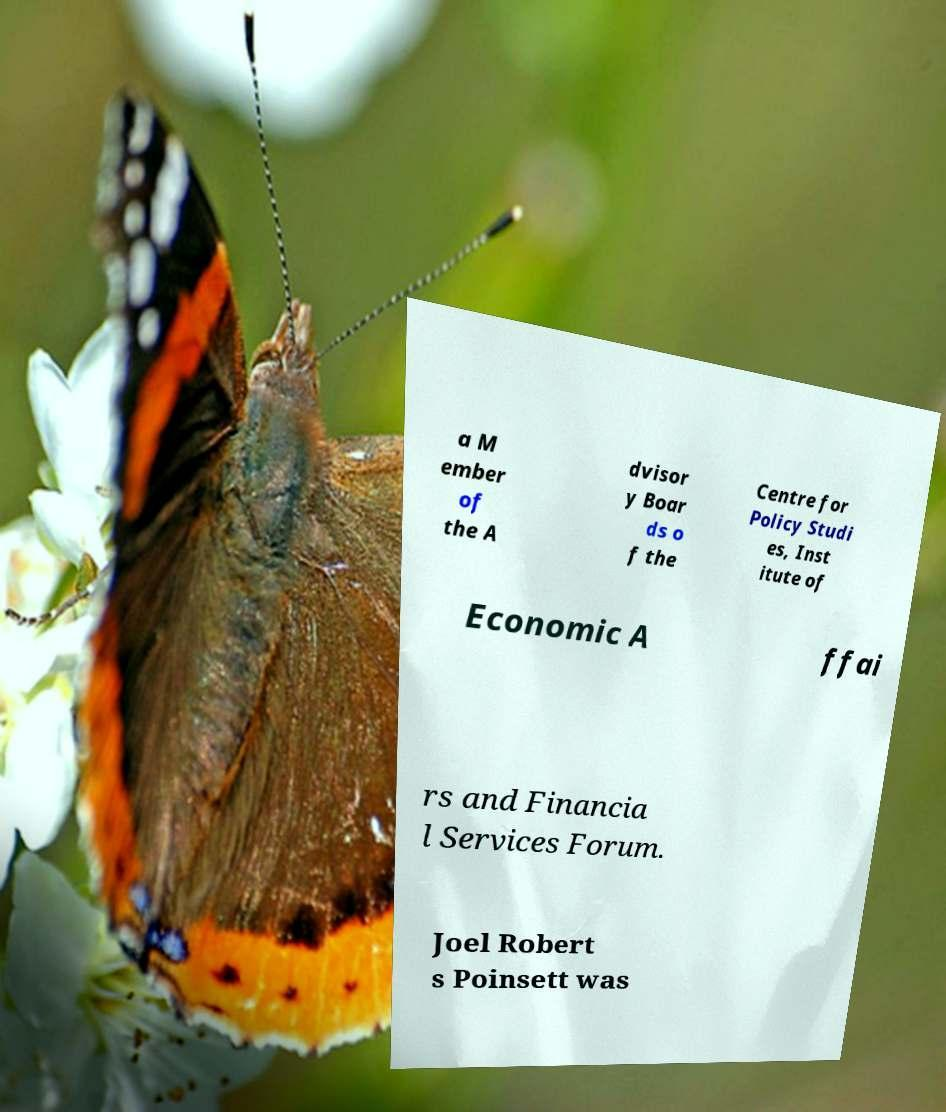For documentation purposes, I need the text within this image transcribed. Could you provide that? a M ember of the A dvisor y Boar ds o f the Centre for Policy Studi es, Inst itute of Economic A ffai rs and Financia l Services Forum. Joel Robert s Poinsett was 